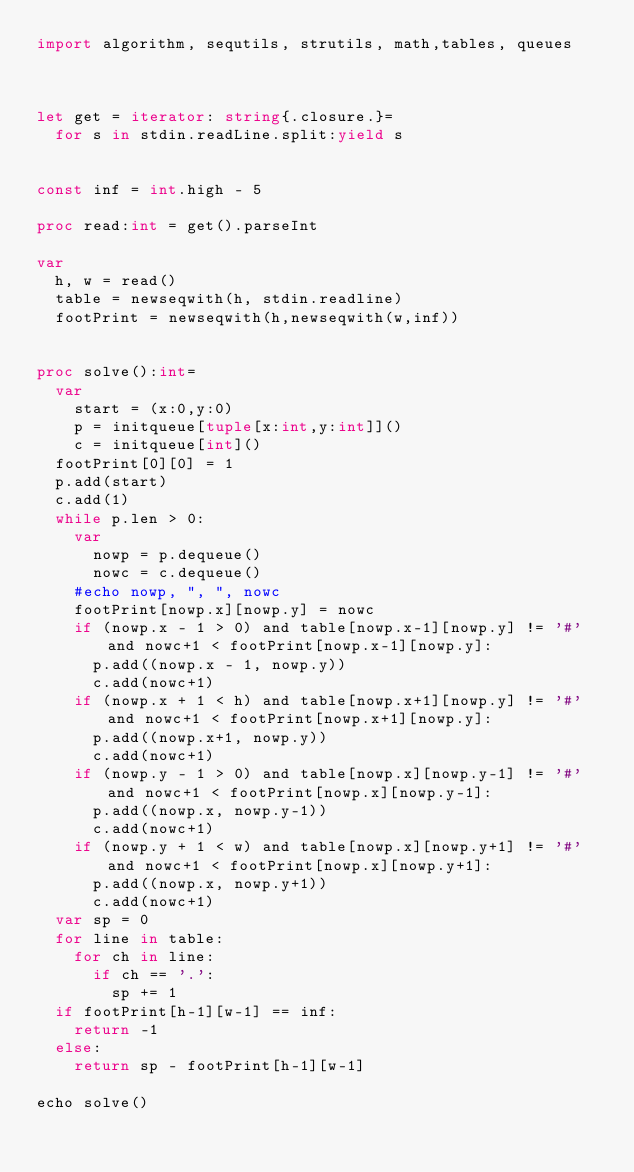<code> <loc_0><loc_0><loc_500><loc_500><_Nim_>import algorithm, sequtils, strutils, math,tables, queues



let get = iterator: string{.closure.}=
  for s in stdin.readLine.split:yield s
 

const inf = int.high - 5

proc read:int = get().parseInt

var
  h, w = read()
  table = newseqwith(h, stdin.readline)
  footPrint = newseqwith(h,newseqwith(w,inf))
  

proc solve():int=
  var
    start = (x:0,y:0)
    p = initqueue[tuple[x:int,y:int]]()
    c = initqueue[int]()
  footPrint[0][0] = 1
  p.add(start)
  c.add(1)
  while p.len > 0:
    var
      nowp = p.dequeue()
      nowc = c.dequeue()
    #echo nowp, ", ", nowc
    footPrint[nowp.x][nowp.y] = nowc
    if (nowp.x - 1 > 0) and table[nowp.x-1][nowp.y] != '#' and nowc+1 < footPrint[nowp.x-1][nowp.y]:
      p.add((nowp.x - 1, nowp.y))
      c.add(nowc+1)
    if (nowp.x + 1 < h) and table[nowp.x+1][nowp.y] != '#' and nowc+1 < footPrint[nowp.x+1][nowp.y]:
      p.add((nowp.x+1, nowp.y))
      c.add(nowc+1)
    if (nowp.y - 1 > 0) and table[nowp.x][nowp.y-1] != '#' and nowc+1 < footPrint[nowp.x][nowp.y-1]:
      p.add((nowp.x, nowp.y-1))
      c.add(nowc+1)
    if (nowp.y + 1 < w) and table[nowp.x][nowp.y+1] != '#' and nowc+1 < footPrint[nowp.x][nowp.y+1]:
      p.add((nowp.x, nowp.y+1))
      c.add(nowc+1)
  var sp = 0
  for line in table:
    for ch in line:
      if ch == '.':
        sp += 1
  if footPrint[h-1][w-1] == inf:
    return -1
  else:
    return sp - footPrint[h-1][w-1]

echo solve()</code> 